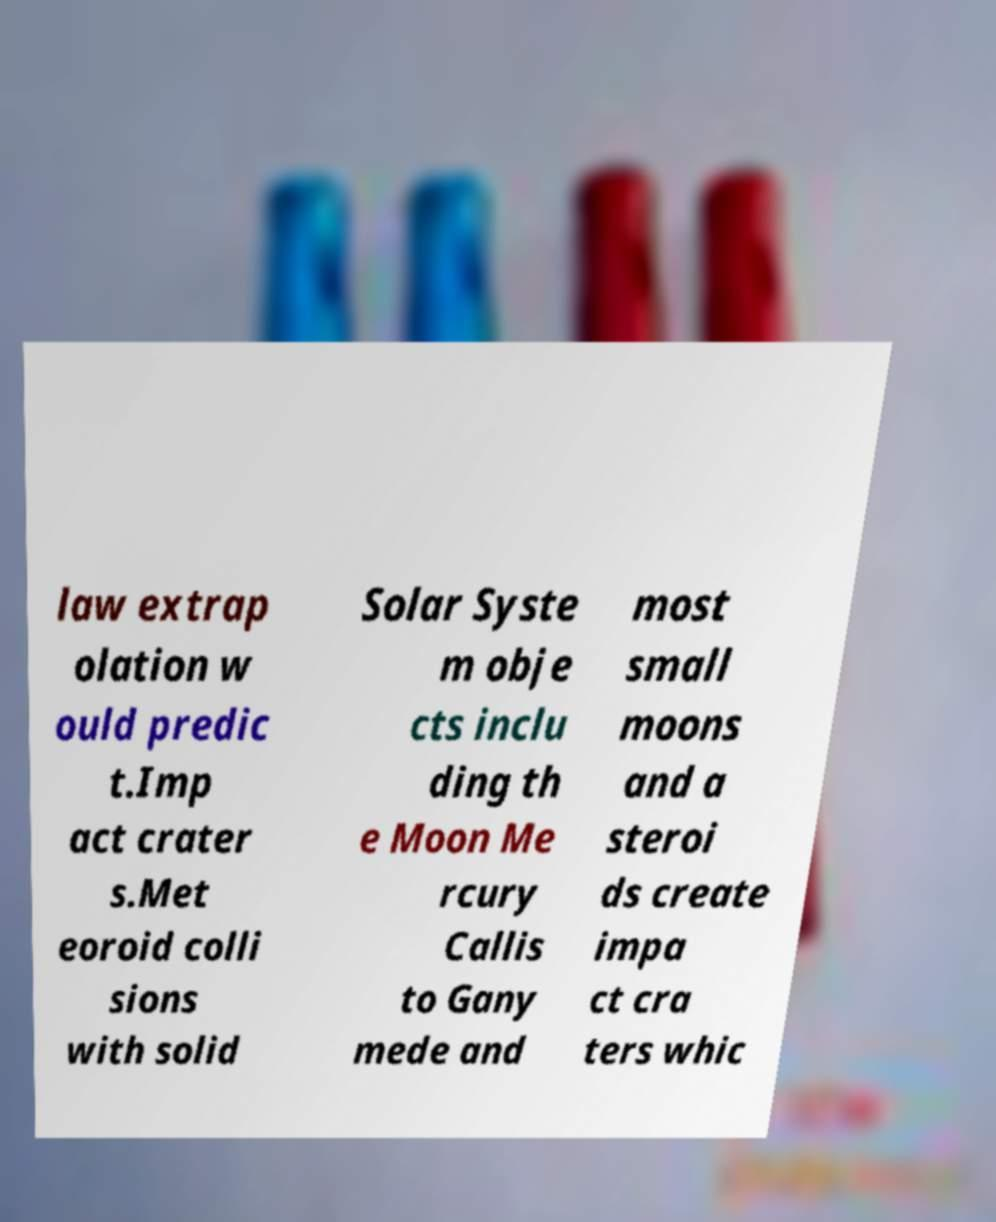Please read and relay the text visible in this image. What does it say? law extrap olation w ould predic t.Imp act crater s.Met eoroid colli sions with solid Solar Syste m obje cts inclu ding th e Moon Me rcury Callis to Gany mede and most small moons and a steroi ds create impa ct cra ters whic 